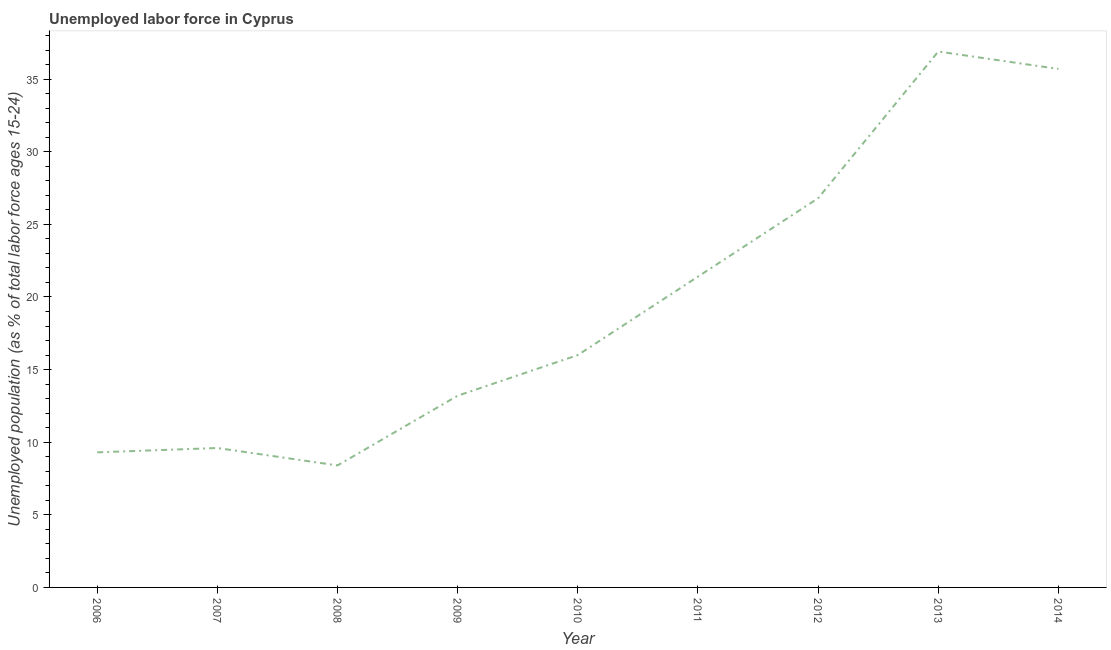What is the total unemployed youth population in 2011?
Keep it short and to the point. 21.4. Across all years, what is the maximum total unemployed youth population?
Offer a very short reply. 36.9. Across all years, what is the minimum total unemployed youth population?
Offer a very short reply. 8.4. What is the sum of the total unemployed youth population?
Your answer should be compact. 177.3. What is the difference between the total unemployed youth population in 2008 and 2013?
Offer a terse response. -28.5. What is the average total unemployed youth population per year?
Offer a very short reply. 19.7. What is the median total unemployed youth population?
Give a very brief answer. 16. In how many years, is the total unemployed youth population greater than 23 %?
Give a very brief answer. 3. What is the ratio of the total unemployed youth population in 2006 to that in 2011?
Your answer should be very brief. 0.43. Is the total unemployed youth population in 2011 less than that in 2013?
Keep it short and to the point. Yes. Is the difference between the total unemployed youth population in 2007 and 2009 greater than the difference between any two years?
Offer a very short reply. No. What is the difference between the highest and the second highest total unemployed youth population?
Keep it short and to the point. 1.2. Is the sum of the total unemployed youth population in 2008 and 2012 greater than the maximum total unemployed youth population across all years?
Offer a very short reply. No. What is the difference between the highest and the lowest total unemployed youth population?
Offer a terse response. 28.5. In how many years, is the total unemployed youth population greater than the average total unemployed youth population taken over all years?
Make the answer very short. 4. How many years are there in the graph?
Provide a succinct answer. 9. Are the values on the major ticks of Y-axis written in scientific E-notation?
Keep it short and to the point. No. Does the graph contain any zero values?
Provide a short and direct response. No. What is the title of the graph?
Give a very brief answer. Unemployed labor force in Cyprus. What is the label or title of the Y-axis?
Provide a short and direct response. Unemployed population (as % of total labor force ages 15-24). What is the Unemployed population (as % of total labor force ages 15-24) of 2006?
Make the answer very short. 9.3. What is the Unemployed population (as % of total labor force ages 15-24) of 2007?
Your answer should be compact. 9.6. What is the Unemployed population (as % of total labor force ages 15-24) in 2008?
Provide a short and direct response. 8.4. What is the Unemployed population (as % of total labor force ages 15-24) in 2009?
Your answer should be compact. 13.2. What is the Unemployed population (as % of total labor force ages 15-24) of 2011?
Your answer should be compact. 21.4. What is the Unemployed population (as % of total labor force ages 15-24) in 2012?
Your answer should be compact. 26.8. What is the Unemployed population (as % of total labor force ages 15-24) in 2013?
Ensure brevity in your answer.  36.9. What is the Unemployed population (as % of total labor force ages 15-24) of 2014?
Make the answer very short. 35.7. What is the difference between the Unemployed population (as % of total labor force ages 15-24) in 2006 and 2007?
Provide a succinct answer. -0.3. What is the difference between the Unemployed population (as % of total labor force ages 15-24) in 2006 and 2008?
Offer a very short reply. 0.9. What is the difference between the Unemployed population (as % of total labor force ages 15-24) in 2006 and 2009?
Offer a terse response. -3.9. What is the difference between the Unemployed population (as % of total labor force ages 15-24) in 2006 and 2011?
Give a very brief answer. -12.1. What is the difference between the Unemployed population (as % of total labor force ages 15-24) in 2006 and 2012?
Your answer should be compact. -17.5. What is the difference between the Unemployed population (as % of total labor force ages 15-24) in 2006 and 2013?
Ensure brevity in your answer.  -27.6. What is the difference between the Unemployed population (as % of total labor force ages 15-24) in 2006 and 2014?
Your response must be concise. -26.4. What is the difference between the Unemployed population (as % of total labor force ages 15-24) in 2007 and 2008?
Your answer should be very brief. 1.2. What is the difference between the Unemployed population (as % of total labor force ages 15-24) in 2007 and 2009?
Provide a short and direct response. -3.6. What is the difference between the Unemployed population (as % of total labor force ages 15-24) in 2007 and 2012?
Keep it short and to the point. -17.2. What is the difference between the Unemployed population (as % of total labor force ages 15-24) in 2007 and 2013?
Offer a terse response. -27.3. What is the difference between the Unemployed population (as % of total labor force ages 15-24) in 2007 and 2014?
Your response must be concise. -26.1. What is the difference between the Unemployed population (as % of total labor force ages 15-24) in 2008 and 2012?
Your response must be concise. -18.4. What is the difference between the Unemployed population (as % of total labor force ages 15-24) in 2008 and 2013?
Provide a short and direct response. -28.5. What is the difference between the Unemployed population (as % of total labor force ages 15-24) in 2008 and 2014?
Ensure brevity in your answer.  -27.3. What is the difference between the Unemployed population (as % of total labor force ages 15-24) in 2009 and 2010?
Ensure brevity in your answer.  -2.8. What is the difference between the Unemployed population (as % of total labor force ages 15-24) in 2009 and 2012?
Make the answer very short. -13.6. What is the difference between the Unemployed population (as % of total labor force ages 15-24) in 2009 and 2013?
Make the answer very short. -23.7. What is the difference between the Unemployed population (as % of total labor force ages 15-24) in 2009 and 2014?
Offer a terse response. -22.5. What is the difference between the Unemployed population (as % of total labor force ages 15-24) in 2010 and 2013?
Your response must be concise. -20.9. What is the difference between the Unemployed population (as % of total labor force ages 15-24) in 2010 and 2014?
Keep it short and to the point. -19.7. What is the difference between the Unemployed population (as % of total labor force ages 15-24) in 2011 and 2013?
Keep it short and to the point. -15.5. What is the difference between the Unemployed population (as % of total labor force ages 15-24) in 2011 and 2014?
Your answer should be very brief. -14.3. What is the difference between the Unemployed population (as % of total labor force ages 15-24) in 2013 and 2014?
Offer a terse response. 1.2. What is the ratio of the Unemployed population (as % of total labor force ages 15-24) in 2006 to that in 2007?
Ensure brevity in your answer.  0.97. What is the ratio of the Unemployed population (as % of total labor force ages 15-24) in 2006 to that in 2008?
Offer a very short reply. 1.11. What is the ratio of the Unemployed population (as % of total labor force ages 15-24) in 2006 to that in 2009?
Make the answer very short. 0.7. What is the ratio of the Unemployed population (as % of total labor force ages 15-24) in 2006 to that in 2010?
Ensure brevity in your answer.  0.58. What is the ratio of the Unemployed population (as % of total labor force ages 15-24) in 2006 to that in 2011?
Provide a succinct answer. 0.43. What is the ratio of the Unemployed population (as % of total labor force ages 15-24) in 2006 to that in 2012?
Your answer should be very brief. 0.35. What is the ratio of the Unemployed population (as % of total labor force ages 15-24) in 2006 to that in 2013?
Provide a short and direct response. 0.25. What is the ratio of the Unemployed population (as % of total labor force ages 15-24) in 2006 to that in 2014?
Offer a very short reply. 0.26. What is the ratio of the Unemployed population (as % of total labor force ages 15-24) in 2007 to that in 2008?
Your answer should be compact. 1.14. What is the ratio of the Unemployed population (as % of total labor force ages 15-24) in 2007 to that in 2009?
Give a very brief answer. 0.73. What is the ratio of the Unemployed population (as % of total labor force ages 15-24) in 2007 to that in 2010?
Your answer should be compact. 0.6. What is the ratio of the Unemployed population (as % of total labor force ages 15-24) in 2007 to that in 2011?
Your answer should be compact. 0.45. What is the ratio of the Unemployed population (as % of total labor force ages 15-24) in 2007 to that in 2012?
Provide a short and direct response. 0.36. What is the ratio of the Unemployed population (as % of total labor force ages 15-24) in 2007 to that in 2013?
Provide a short and direct response. 0.26. What is the ratio of the Unemployed population (as % of total labor force ages 15-24) in 2007 to that in 2014?
Your response must be concise. 0.27. What is the ratio of the Unemployed population (as % of total labor force ages 15-24) in 2008 to that in 2009?
Give a very brief answer. 0.64. What is the ratio of the Unemployed population (as % of total labor force ages 15-24) in 2008 to that in 2010?
Ensure brevity in your answer.  0.53. What is the ratio of the Unemployed population (as % of total labor force ages 15-24) in 2008 to that in 2011?
Your answer should be compact. 0.39. What is the ratio of the Unemployed population (as % of total labor force ages 15-24) in 2008 to that in 2012?
Your answer should be very brief. 0.31. What is the ratio of the Unemployed population (as % of total labor force ages 15-24) in 2008 to that in 2013?
Your response must be concise. 0.23. What is the ratio of the Unemployed population (as % of total labor force ages 15-24) in 2008 to that in 2014?
Provide a short and direct response. 0.23. What is the ratio of the Unemployed population (as % of total labor force ages 15-24) in 2009 to that in 2010?
Your answer should be compact. 0.82. What is the ratio of the Unemployed population (as % of total labor force ages 15-24) in 2009 to that in 2011?
Your answer should be very brief. 0.62. What is the ratio of the Unemployed population (as % of total labor force ages 15-24) in 2009 to that in 2012?
Keep it short and to the point. 0.49. What is the ratio of the Unemployed population (as % of total labor force ages 15-24) in 2009 to that in 2013?
Your answer should be compact. 0.36. What is the ratio of the Unemployed population (as % of total labor force ages 15-24) in 2009 to that in 2014?
Offer a terse response. 0.37. What is the ratio of the Unemployed population (as % of total labor force ages 15-24) in 2010 to that in 2011?
Give a very brief answer. 0.75. What is the ratio of the Unemployed population (as % of total labor force ages 15-24) in 2010 to that in 2012?
Ensure brevity in your answer.  0.6. What is the ratio of the Unemployed population (as % of total labor force ages 15-24) in 2010 to that in 2013?
Your response must be concise. 0.43. What is the ratio of the Unemployed population (as % of total labor force ages 15-24) in 2010 to that in 2014?
Make the answer very short. 0.45. What is the ratio of the Unemployed population (as % of total labor force ages 15-24) in 2011 to that in 2012?
Your answer should be compact. 0.8. What is the ratio of the Unemployed population (as % of total labor force ages 15-24) in 2011 to that in 2013?
Provide a succinct answer. 0.58. What is the ratio of the Unemployed population (as % of total labor force ages 15-24) in 2011 to that in 2014?
Ensure brevity in your answer.  0.6. What is the ratio of the Unemployed population (as % of total labor force ages 15-24) in 2012 to that in 2013?
Your answer should be very brief. 0.73. What is the ratio of the Unemployed population (as % of total labor force ages 15-24) in 2012 to that in 2014?
Your response must be concise. 0.75. What is the ratio of the Unemployed population (as % of total labor force ages 15-24) in 2013 to that in 2014?
Your answer should be very brief. 1.03. 